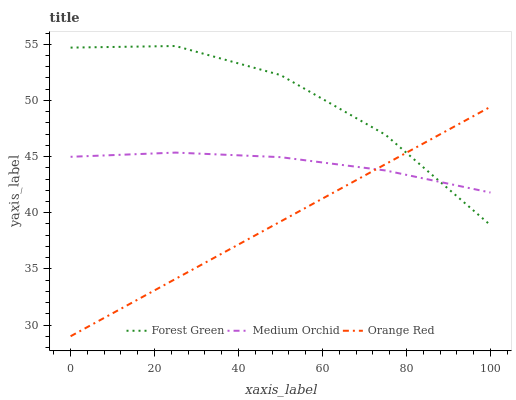Does Orange Red have the minimum area under the curve?
Answer yes or no. Yes. Does Forest Green have the maximum area under the curve?
Answer yes or no. Yes. Does Medium Orchid have the minimum area under the curve?
Answer yes or no. No. Does Medium Orchid have the maximum area under the curve?
Answer yes or no. No. Is Orange Red the smoothest?
Answer yes or no. Yes. Is Forest Green the roughest?
Answer yes or no. Yes. Is Medium Orchid the smoothest?
Answer yes or no. No. Is Medium Orchid the roughest?
Answer yes or no. No. Does Medium Orchid have the lowest value?
Answer yes or no. No. Does Forest Green have the highest value?
Answer yes or no. Yes. Does Orange Red have the highest value?
Answer yes or no. No. Does Medium Orchid intersect Forest Green?
Answer yes or no. Yes. Is Medium Orchid less than Forest Green?
Answer yes or no. No. Is Medium Orchid greater than Forest Green?
Answer yes or no. No. 